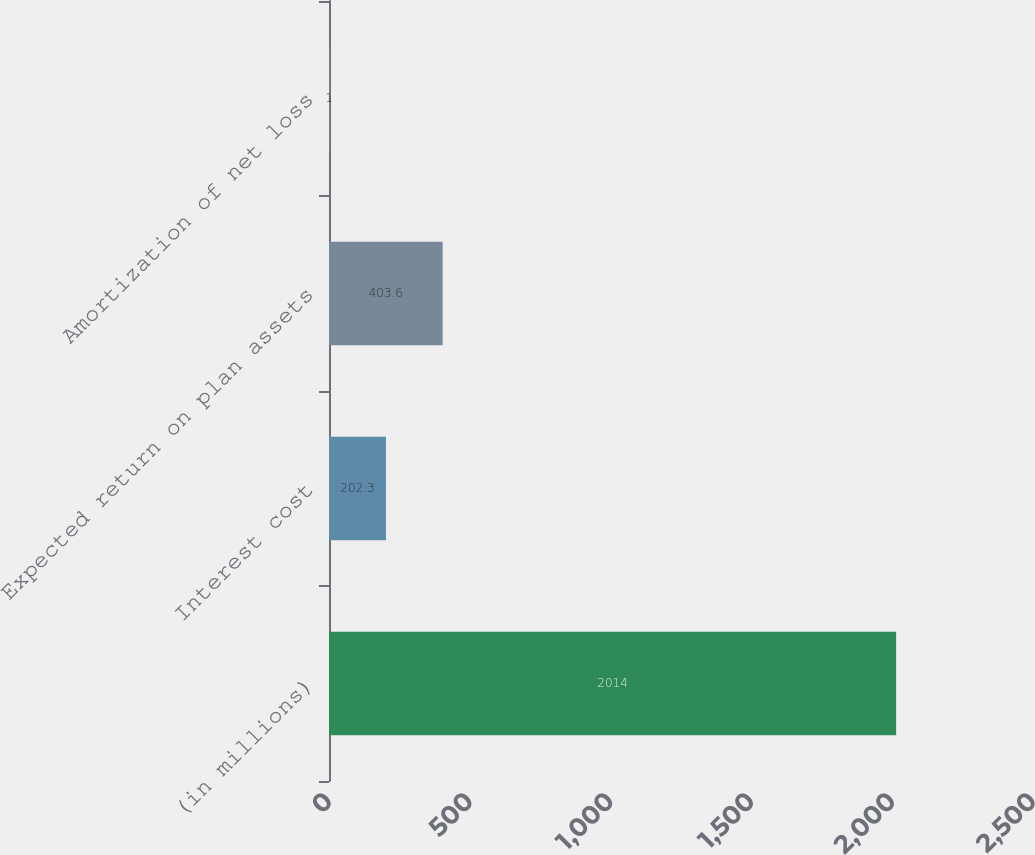Convert chart to OTSL. <chart><loc_0><loc_0><loc_500><loc_500><bar_chart><fcel>(in millions)<fcel>Interest cost<fcel>Expected return on plan assets<fcel>Amortization of net loss<nl><fcel>2014<fcel>202.3<fcel>403.6<fcel>1<nl></chart> 